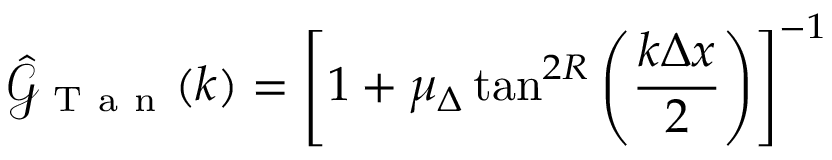<formula> <loc_0><loc_0><loc_500><loc_500>\hat { \mathcal { G } } _ { T a n } ( k ) = \left [ 1 + \mu _ { \Delta } \tan ^ { 2 R } \left ( \frac { k \Delta x } { 2 } \right ) \right ] ^ { - 1 }</formula> 